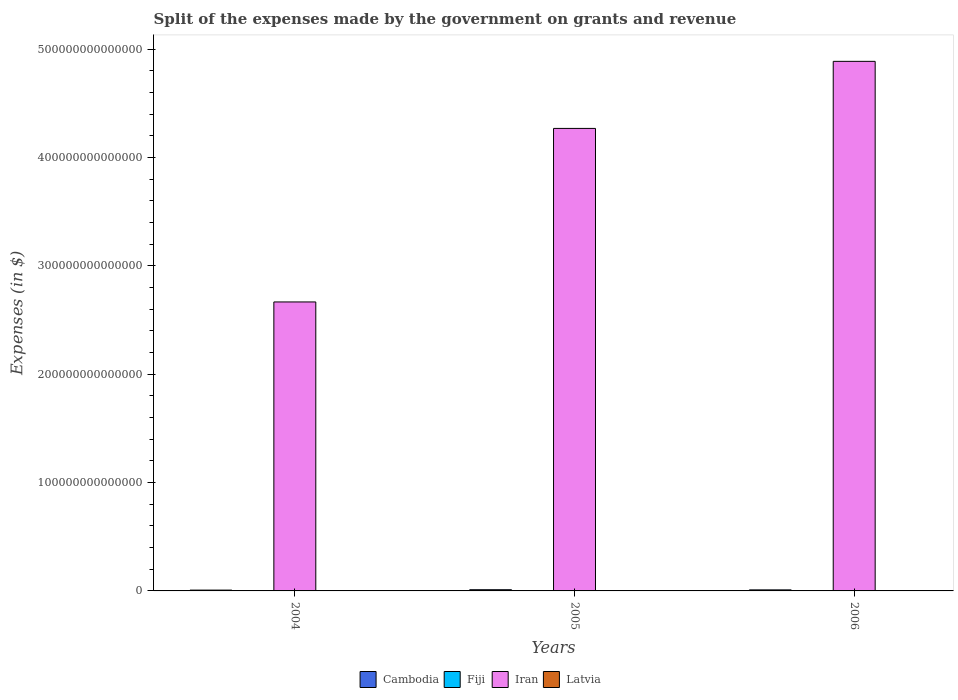How many bars are there on the 2nd tick from the right?
Your answer should be very brief. 4. What is the expenses made by the government on grants and revenue in Cambodia in 2004?
Provide a short and direct response. 7.57e+11. Across all years, what is the maximum expenses made by the government on grants and revenue in Iran?
Your answer should be compact. 4.89e+14. Across all years, what is the minimum expenses made by the government on grants and revenue in Fiji?
Your response must be concise. 1.27e+08. What is the total expenses made by the government on grants and revenue in Fiji in the graph?
Offer a very short reply. 3.93e+08. What is the difference between the expenses made by the government on grants and revenue in Latvia in 2005 and that in 2006?
Give a very brief answer. -5.76e+07. What is the difference between the expenses made by the government on grants and revenue in Cambodia in 2005 and the expenses made by the government on grants and revenue in Iran in 2006?
Provide a short and direct response. -4.88e+14. What is the average expenses made by the government on grants and revenue in Cambodia per year?
Give a very brief answer. 9.39e+11. In the year 2004, what is the difference between the expenses made by the government on grants and revenue in Cambodia and expenses made by the government on grants and revenue in Fiji?
Offer a terse response. 7.57e+11. What is the ratio of the expenses made by the government on grants and revenue in Cambodia in 2005 to that in 2006?
Provide a succinct answer. 1.15. Is the expenses made by the government on grants and revenue in Latvia in 2005 less than that in 2006?
Provide a succinct answer. Yes. Is the difference between the expenses made by the government on grants and revenue in Cambodia in 2004 and 2006 greater than the difference between the expenses made by the government on grants and revenue in Fiji in 2004 and 2006?
Offer a very short reply. No. What is the difference between the highest and the second highest expenses made by the government on grants and revenue in Cambodia?
Offer a terse response. 1.44e+11. What is the difference between the highest and the lowest expenses made by the government on grants and revenue in Fiji?
Provide a succinct answer. 1.07e+07. In how many years, is the expenses made by the government on grants and revenue in Latvia greater than the average expenses made by the government on grants and revenue in Latvia taken over all years?
Your response must be concise. 2. What does the 1st bar from the left in 2005 represents?
Offer a terse response. Cambodia. What does the 2nd bar from the right in 2005 represents?
Ensure brevity in your answer.  Iran. Is it the case that in every year, the sum of the expenses made by the government on grants and revenue in Cambodia and expenses made by the government on grants and revenue in Iran is greater than the expenses made by the government on grants and revenue in Latvia?
Offer a terse response. Yes. How many bars are there?
Keep it short and to the point. 12. Are all the bars in the graph horizontal?
Offer a terse response. No. What is the difference between two consecutive major ticks on the Y-axis?
Make the answer very short. 1.00e+14. Are the values on the major ticks of Y-axis written in scientific E-notation?
Offer a terse response. No. Does the graph contain grids?
Ensure brevity in your answer.  No. How are the legend labels stacked?
Your answer should be compact. Horizontal. What is the title of the graph?
Give a very brief answer. Split of the expenses made by the government on grants and revenue. What is the label or title of the X-axis?
Offer a very short reply. Years. What is the label or title of the Y-axis?
Ensure brevity in your answer.  Expenses (in $). What is the Expenses (in $) of Cambodia in 2004?
Your answer should be compact. 7.57e+11. What is the Expenses (in $) of Fiji in 2004?
Offer a terse response. 1.27e+08. What is the Expenses (in $) in Iran in 2004?
Your response must be concise. 2.67e+14. What is the Expenses (in $) in Latvia in 2004?
Keep it short and to the point. 4.03e+08. What is the Expenses (in $) of Cambodia in 2005?
Offer a very short reply. 1.10e+12. What is the Expenses (in $) in Fiji in 2005?
Offer a terse response. 1.38e+08. What is the Expenses (in $) of Iran in 2005?
Make the answer very short. 4.27e+14. What is the Expenses (in $) of Latvia in 2005?
Give a very brief answer. 5.18e+08. What is the Expenses (in $) of Cambodia in 2006?
Your answer should be very brief. 9.57e+11. What is the Expenses (in $) of Fiji in 2006?
Provide a succinct answer. 1.28e+08. What is the Expenses (in $) of Iran in 2006?
Provide a succinct answer. 4.89e+14. What is the Expenses (in $) of Latvia in 2006?
Your answer should be very brief. 5.75e+08. Across all years, what is the maximum Expenses (in $) of Cambodia?
Provide a short and direct response. 1.10e+12. Across all years, what is the maximum Expenses (in $) in Fiji?
Provide a succinct answer. 1.38e+08. Across all years, what is the maximum Expenses (in $) in Iran?
Your answer should be compact. 4.89e+14. Across all years, what is the maximum Expenses (in $) in Latvia?
Provide a succinct answer. 5.75e+08. Across all years, what is the minimum Expenses (in $) in Cambodia?
Keep it short and to the point. 7.57e+11. Across all years, what is the minimum Expenses (in $) in Fiji?
Offer a very short reply. 1.27e+08. Across all years, what is the minimum Expenses (in $) in Iran?
Keep it short and to the point. 2.67e+14. Across all years, what is the minimum Expenses (in $) of Latvia?
Your response must be concise. 4.03e+08. What is the total Expenses (in $) in Cambodia in the graph?
Keep it short and to the point. 2.82e+12. What is the total Expenses (in $) in Fiji in the graph?
Keep it short and to the point. 3.93e+08. What is the total Expenses (in $) in Iran in the graph?
Ensure brevity in your answer.  1.18e+15. What is the total Expenses (in $) of Latvia in the graph?
Your answer should be very brief. 1.50e+09. What is the difference between the Expenses (in $) in Cambodia in 2004 and that in 2005?
Your answer should be compact. -3.44e+11. What is the difference between the Expenses (in $) of Fiji in 2004 and that in 2005?
Provide a succinct answer. -1.07e+07. What is the difference between the Expenses (in $) in Iran in 2004 and that in 2005?
Your response must be concise. -1.60e+14. What is the difference between the Expenses (in $) in Latvia in 2004 and that in 2005?
Provide a short and direct response. -1.14e+08. What is the difference between the Expenses (in $) in Cambodia in 2004 and that in 2006?
Provide a short and direct response. -2.00e+11. What is the difference between the Expenses (in $) of Fiji in 2004 and that in 2006?
Give a very brief answer. -4.86e+05. What is the difference between the Expenses (in $) of Iran in 2004 and that in 2006?
Provide a short and direct response. -2.22e+14. What is the difference between the Expenses (in $) of Latvia in 2004 and that in 2006?
Your answer should be very brief. -1.72e+08. What is the difference between the Expenses (in $) in Cambodia in 2005 and that in 2006?
Keep it short and to the point. 1.44e+11. What is the difference between the Expenses (in $) of Fiji in 2005 and that in 2006?
Your answer should be compact. 1.02e+07. What is the difference between the Expenses (in $) of Iran in 2005 and that in 2006?
Your answer should be compact. -6.19e+13. What is the difference between the Expenses (in $) of Latvia in 2005 and that in 2006?
Ensure brevity in your answer.  -5.76e+07. What is the difference between the Expenses (in $) in Cambodia in 2004 and the Expenses (in $) in Fiji in 2005?
Your response must be concise. 7.57e+11. What is the difference between the Expenses (in $) in Cambodia in 2004 and the Expenses (in $) in Iran in 2005?
Your answer should be compact. -4.26e+14. What is the difference between the Expenses (in $) in Cambodia in 2004 and the Expenses (in $) in Latvia in 2005?
Keep it short and to the point. 7.57e+11. What is the difference between the Expenses (in $) in Fiji in 2004 and the Expenses (in $) in Iran in 2005?
Offer a very short reply. -4.27e+14. What is the difference between the Expenses (in $) of Fiji in 2004 and the Expenses (in $) of Latvia in 2005?
Give a very brief answer. -3.90e+08. What is the difference between the Expenses (in $) of Iran in 2004 and the Expenses (in $) of Latvia in 2005?
Offer a terse response. 2.67e+14. What is the difference between the Expenses (in $) in Cambodia in 2004 and the Expenses (in $) in Fiji in 2006?
Your answer should be compact. 7.57e+11. What is the difference between the Expenses (in $) of Cambodia in 2004 and the Expenses (in $) of Iran in 2006?
Ensure brevity in your answer.  -4.88e+14. What is the difference between the Expenses (in $) in Cambodia in 2004 and the Expenses (in $) in Latvia in 2006?
Ensure brevity in your answer.  7.57e+11. What is the difference between the Expenses (in $) of Fiji in 2004 and the Expenses (in $) of Iran in 2006?
Make the answer very short. -4.89e+14. What is the difference between the Expenses (in $) in Fiji in 2004 and the Expenses (in $) in Latvia in 2006?
Ensure brevity in your answer.  -4.48e+08. What is the difference between the Expenses (in $) in Iran in 2004 and the Expenses (in $) in Latvia in 2006?
Provide a short and direct response. 2.67e+14. What is the difference between the Expenses (in $) in Cambodia in 2005 and the Expenses (in $) in Fiji in 2006?
Your response must be concise. 1.10e+12. What is the difference between the Expenses (in $) of Cambodia in 2005 and the Expenses (in $) of Iran in 2006?
Offer a terse response. -4.88e+14. What is the difference between the Expenses (in $) of Cambodia in 2005 and the Expenses (in $) of Latvia in 2006?
Give a very brief answer. 1.10e+12. What is the difference between the Expenses (in $) of Fiji in 2005 and the Expenses (in $) of Iran in 2006?
Provide a succinct answer. -4.89e+14. What is the difference between the Expenses (in $) in Fiji in 2005 and the Expenses (in $) in Latvia in 2006?
Provide a succinct answer. -4.37e+08. What is the difference between the Expenses (in $) of Iran in 2005 and the Expenses (in $) of Latvia in 2006?
Your answer should be very brief. 4.27e+14. What is the average Expenses (in $) of Cambodia per year?
Keep it short and to the point. 9.39e+11. What is the average Expenses (in $) in Fiji per year?
Your answer should be compact. 1.31e+08. What is the average Expenses (in $) of Iran per year?
Your answer should be compact. 3.94e+14. What is the average Expenses (in $) in Latvia per year?
Ensure brevity in your answer.  4.99e+08. In the year 2004, what is the difference between the Expenses (in $) of Cambodia and Expenses (in $) of Fiji?
Provide a short and direct response. 7.57e+11. In the year 2004, what is the difference between the Expenses (in $) of Cambodia and Expenses (in $) of Iran?
Provide a short and direct response. -2.66e+14. In the year 2004, what is the difference between the Expenses (in $) in Cambodia and Expenses (in $) in Latvia?
Provide a succinct answer. 7.57e+11. In the year 2004, what is the difference between the Expenses (in $) in Fiji and Expenses (in $) in Iran?
Provide a short and direct response. -2.67e+14. In the year 2004, what is the difference between the Expenses (in $) of Fiji and Expenses (in $) of Latvia?
Your answer should be very brief. -2.76e+08. In the year 2004, what is the difference between the Expenses (in $) in Iran and Expenses (in $) in Latvia?
Make the answer very short. 2.67e+14. In the year 2005, what is the difference between the Expenses (in $) in Cambodia and Expenses (in $) in Fiji?
Give a very brief answer. 1.10e+12. In the year 2005, what is the difference between the Expenses (in $) of Cambodia and Expenses (in $) of Iran?
Your answer should be compact. -4.26e+14. In the year 2005, what is the difference between the Expenses (in $) in Cambodia and Expenses (in $) in Latvia?
Make the answer very short. 1.10e+12. In the year 2005, what is the difference between the Expenses (in $) in Fiji and Expenses (in $) in Iran?
Provide a succinct answer. -4.27e+14. In the year 2005, what is the difference between the Expenses (in $) of Fiji and Expenses (in $) of Latvia?
Your answer should be very brief. -3.80e+08. In the year 2005, what is the difference between the Expenses (in $) in Iran and Expenses (in $) in Latvia?
Make the answer very short. 4.27e+14. In the year 2006, what is the difference between the Expenses (in $) in Cambodia and Expenses (in $) in Fiji?
Offer a very short reply. 9.57e+11. In the year 2006, what is the difference between the Expenses (in $) in Cambodia and Expenses (in $) in Iran?
Your answer should be compact. -4.88e+14. In the year 2006, what is the difference between the Expenses (in $) in Cambodia and Expenses (in $) in Latvia?
Your answer should be very brief. 9.57e+11. In the year 2006, what is the difference between the Expenses (in $) of Fiji and Expenses (in $) of Iran?
Provide a short and direct response. -4.89e+14. In the year 2006, what is the difference between the Expenses (in $) of Fiji and Expenses (in $) of Latvia?
Your response must be concise. -4.48e+08. In the year 2006, what is the difference between the Expenses (in $) of Iran and Expenses (in $) of Latvia?
Give a very brief answer. 4.89e+14. What is the ratio of the Expenses (in $) in Cambodia in 2004 to that in 2005?
Offer a terse response. 0.69. What is the ratio of the Expenses (in $) in Fiji in 2004 to that in 2005?
Give a very brief answer. 0.92. What is the ratio of the Expenses (in $) of Iran in 2004 to that in 2005?
Your answer should be very brief. 0.62. What is the ratio of the Expenses (in $) of Latvia in 2004 to that in 2005?
Your response must be concise. 0.78. What is the ratio of the Expenses (in $) of Cambodia in 2004 to that in 2006?
Give a very brief answer. 0.79. What is the ratio of the Expenses (in $) in Fiji in 2004 to that in 2006?
Offer a very short reply. 1. What is the ratio of the Expenses (in $) in Iran in 2004 to that in 2006?
Give a very brief answer. 0.55. What is the ratio of the Expenses (in $) in Latvia in 2004 to that in 2006?
Offer a very short reply. 0.7. What is the ratio of the Expenses (in $) in Cambodia in 2005 to that in 2006?
Provide a short and direct response. 1.15. What is the ratio of the Expenses (in $) in Fiji in 2005 to that in 2006?
Offer a very short reply. 1.08. What is the ratio of the Expenses (in $) in Iran in 2005 to that in 2006?
Your response must be concise. 0.87. What is the ratio of the Expenses (in $) of Latvia in 2005 to that in 2006?
Offer a terse response. 0.9. What is the difference between the highest and the second highest Expenses (in $) in Cambodia?
Ensure brevity in your answer.  1.44e+11. What is the difference between the highest and the second highest Expenses (in $) in Fiji?
Provide a succinct answer. 1.02e+07. What is the difference between the highest and the second highest Expenses (in $) in Iran?
Your answer should be compact. 6.19e+13. What is the difference between the highest and the second highest Expenses (in $) of Latvia?
Provide a succinct answer. 5.76e+07. What is the difference between the highest and the lowest Expenses (in $) of Cambodia?
Make the answer very short. 3.44e+11. What is the difference between the highest and the lowest Expenses (in $) in Fiji?
Your answer should be very brief. 1.07e+07. What is the difference between the highest and the lowest Expenses (in $) of Iran?
Your answer should be very brief. 2.22e+14. What is the difference between the highest and the lowest Expenses (in $) of Latvia?
Your answer should be very brief. 1.72e+08. 